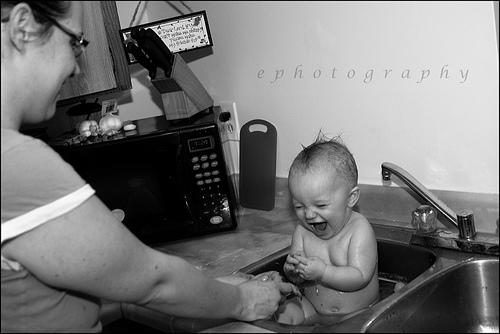Who is most likely bathing the baby? Please explain your reasoning. mom. Usually a child this young receiving care in the home would be receiving that care from their closest relation and primary caregiver. 